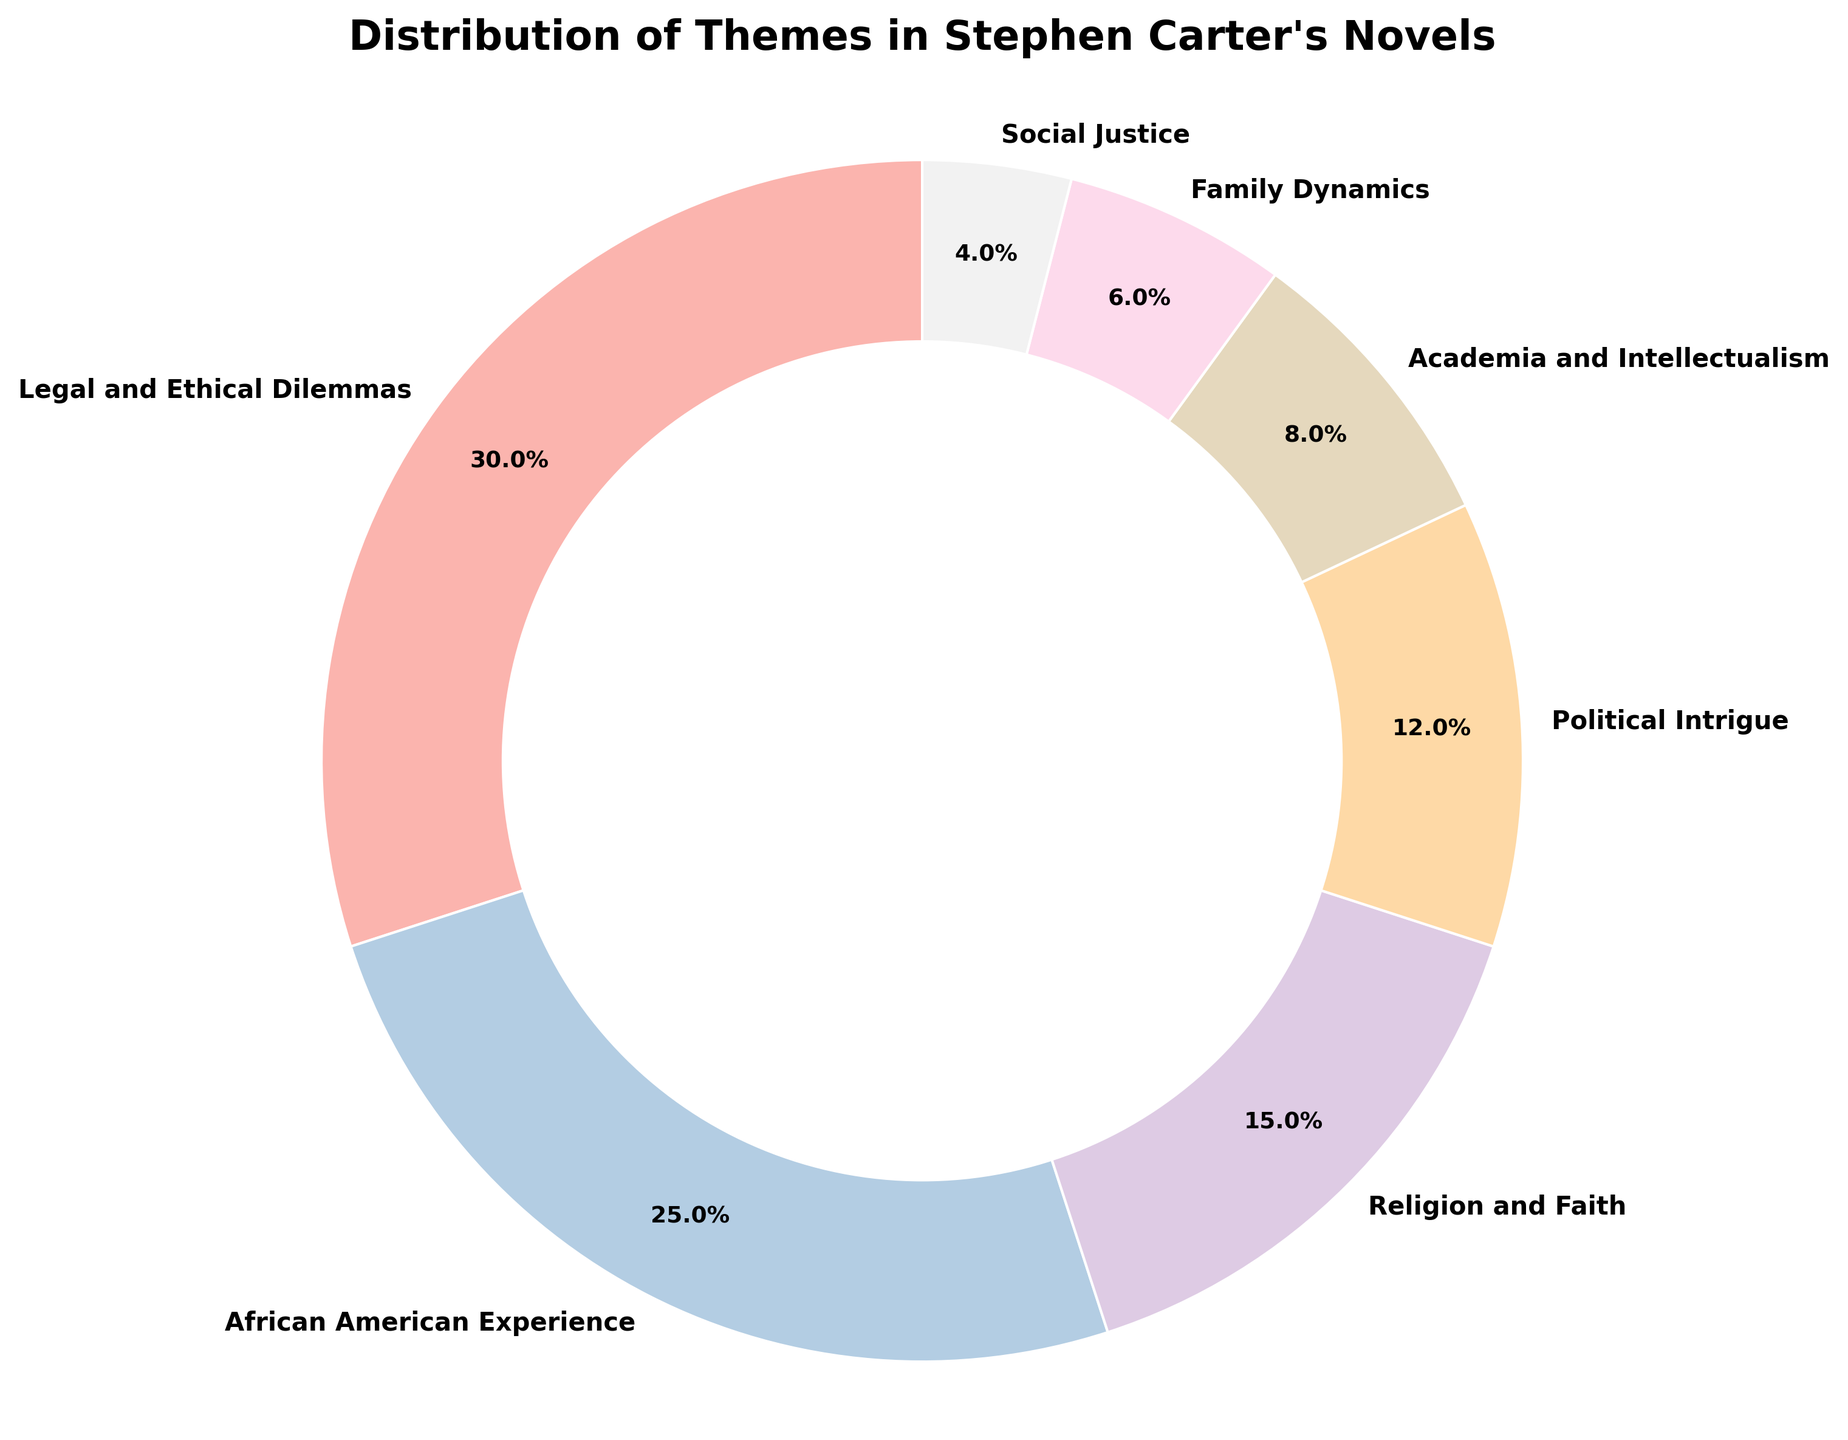What's the most prevalent theme in Stephen Carter's novels? The figure shows a pie chart with various themes and their percentages. The segment labeled "Legal and Ethical Dilemmas" is the largest, occupying 30% of the chart.
Answer: Legal and Ethical Dilemmas How much larger is the "Legal and Ethical Dilemmas" segment compared to "Political Intrigue"? The "Legal and Ethical Dilemmas" segment shows 30%, while the "Political Intrigue" segment shows 12%. Subtracting these values, 30% - 12% = 18%.
Answer: 18% Which two themes combined make up less than 10% of the total? The themes "Family Dynamics" and "Social Justice" show 6% and 4%, respectively. Adding these percentages results in 6% + 4% = 10%.
Answer: Family Dynamics and Social Justice Which theme occupies the second largest portion of the pie chart? The pie chart shows the segments and their percentages. The "African American Experience" segment is the second largest at 25%.
Answer: African American Experience If you combine the segments "Religion and Faith" and "Academia and Intellectualism," how do they compare in size to the "African American Experience" segment? The combined percentage of "Religion and Faith" and "Academia and Intellectualism" is 15% + 8% = 23%. The segment "African American Experience" is 25%. Therefore, 23% is less than 25%.
Answer: Less What percentage of the themes involve aspects outside of legal contexts? The non-legal themes are "African American Experience" (25%), "Religion and Faith" (15%), "Political Intrigue" (12%), "Academia and Intellectualism" (8%), "Family Dynamics" (6%), and "Social Justice" (4%). Adding these percentages results in 25% + 15% + 12% + 8% + 6% + 4% = 70%.
Answer: 70% Which themes combined make up over half of the total distribution? The themes "Legal and Ethical Dilemmas" (30%) and "African American Experience" (25%) together make 30% + 25% = 55%, which is more than half of 100%.
Answer: Legal and Ethical Dilemmas and African American Experience What visual element is used to enhance readability by separating the central area of the pie chart? The figure features a white circle at the center of the pie chart, which separates the sections from the middle part of the chart. This element helps reduce visual clutter and enhances readability.
Answer: White circle How does the "Religion and Faith" segment compare percentage-wise to "Political Intrigue" and "Family Dynamics" combined? Adding the percentages of "Political Intrigue" (12%) and "Family Dynamics" (6%) gives 12% + 6% = 18%. The "Religion and Faith" segment is 15%. Therefore, "Religion and Faith" is smaller than "Political Intrigue" and "Family Dynamics" combined.
Answer: Smaller 